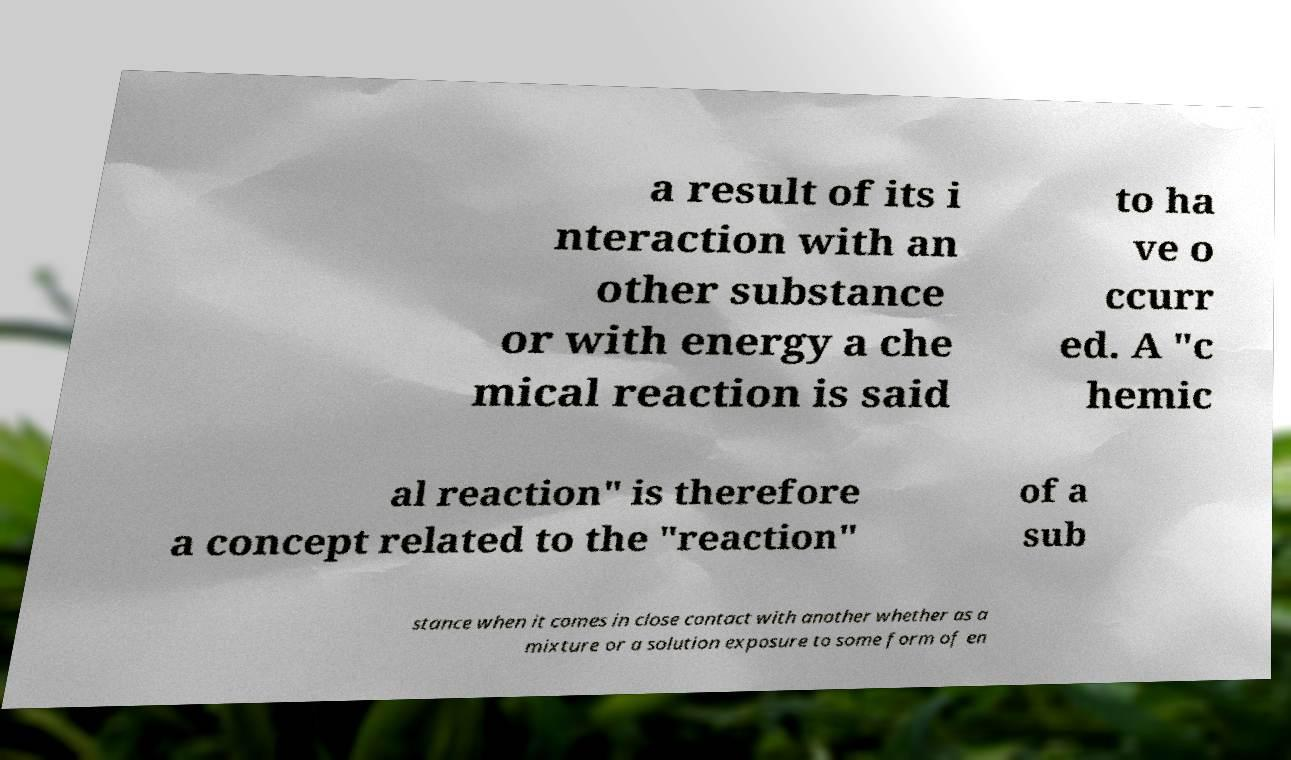Could you extract and type out the text from this image? a result of its i nteraction with an other substance or with energy a che mical reaction is said to ha ve o ccurr ed. A "c hemic al reaction" is therefore a concept related to the "reaction" of a sub stance when it comes in close contact with another whether as a mixture or a solution exposure to some form of en 